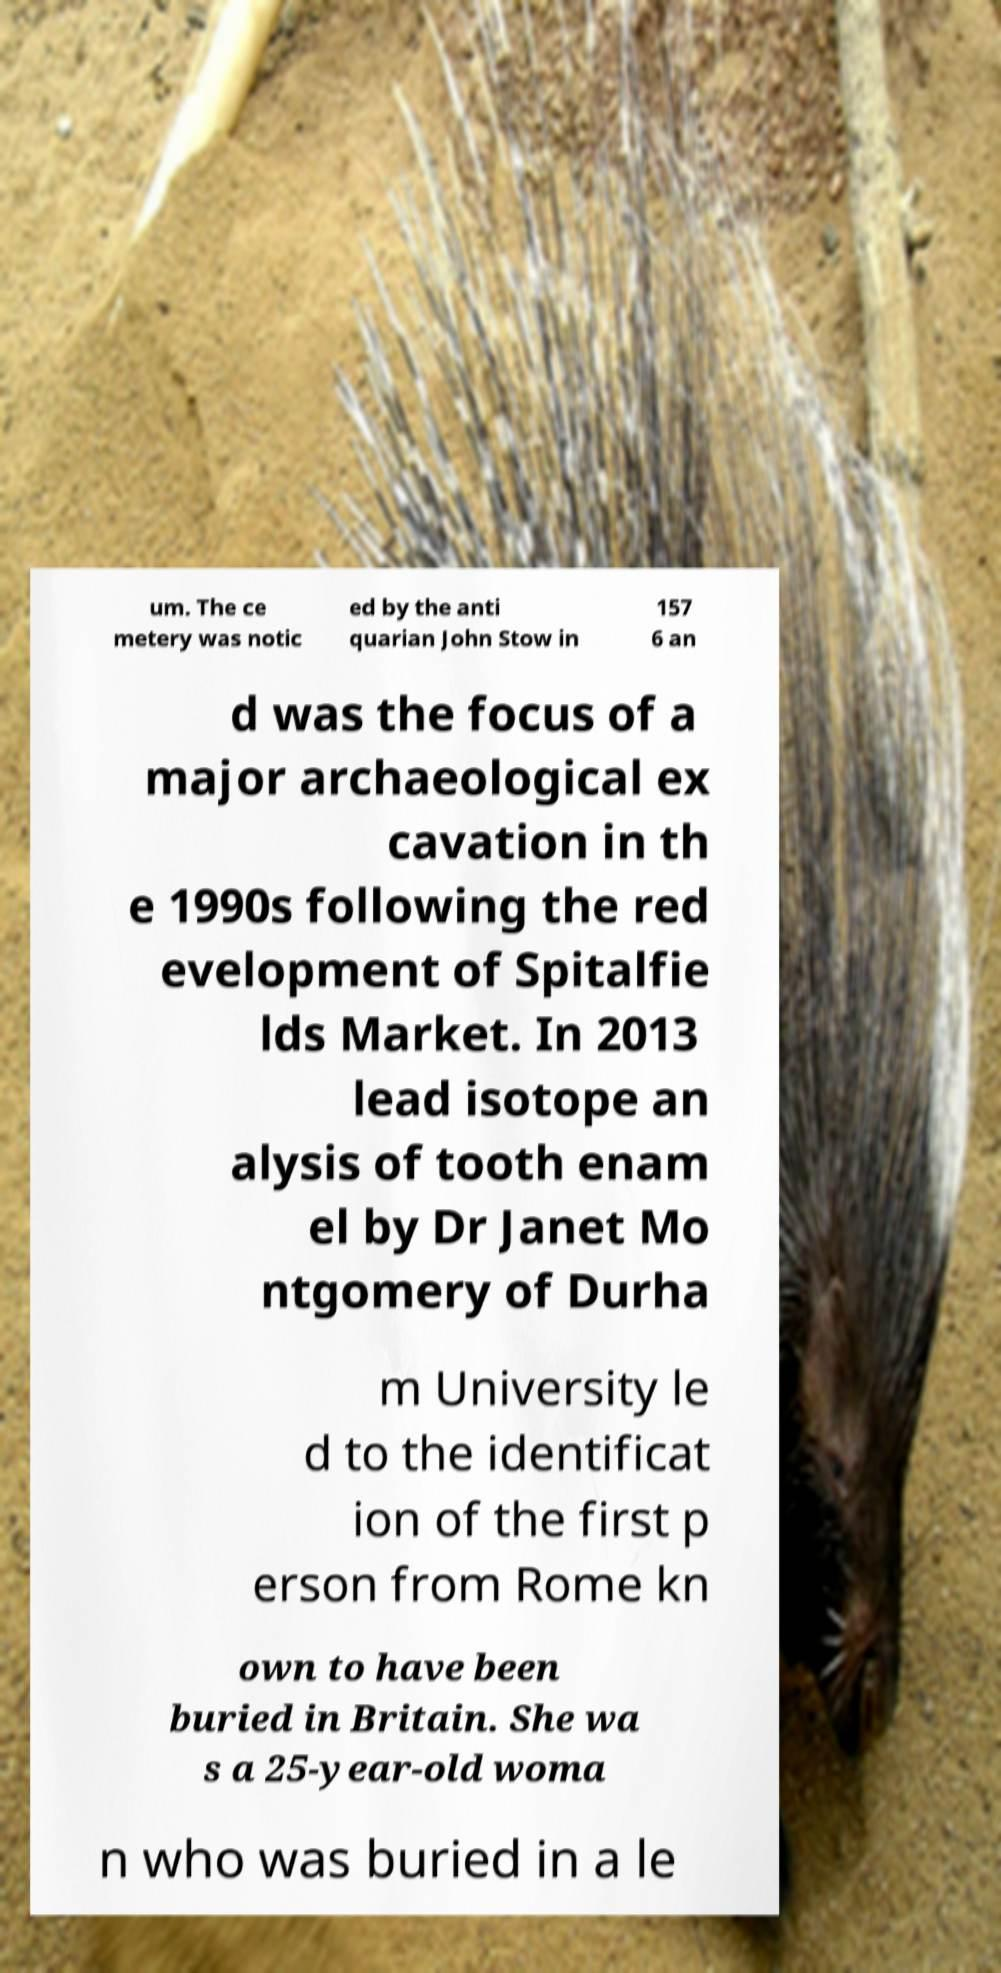Please read and relay the text visible in this image. What does it say? um. The ce metery was notic ed by the anti quarian John Stow in 157 6 an d was the focus of a major archaeological ex cavation in th e 1990s following the red evelopment of Spitalfie lds Market. In 2013 lead isotope an alysis of tooth enam el by Dr Janet Mo ntgomery of Durha m University le d to the identificat ion of the first p erson from Rome kn own to have been buried in Britain. She wa s a 25-year-old woma n who was buried in a le 